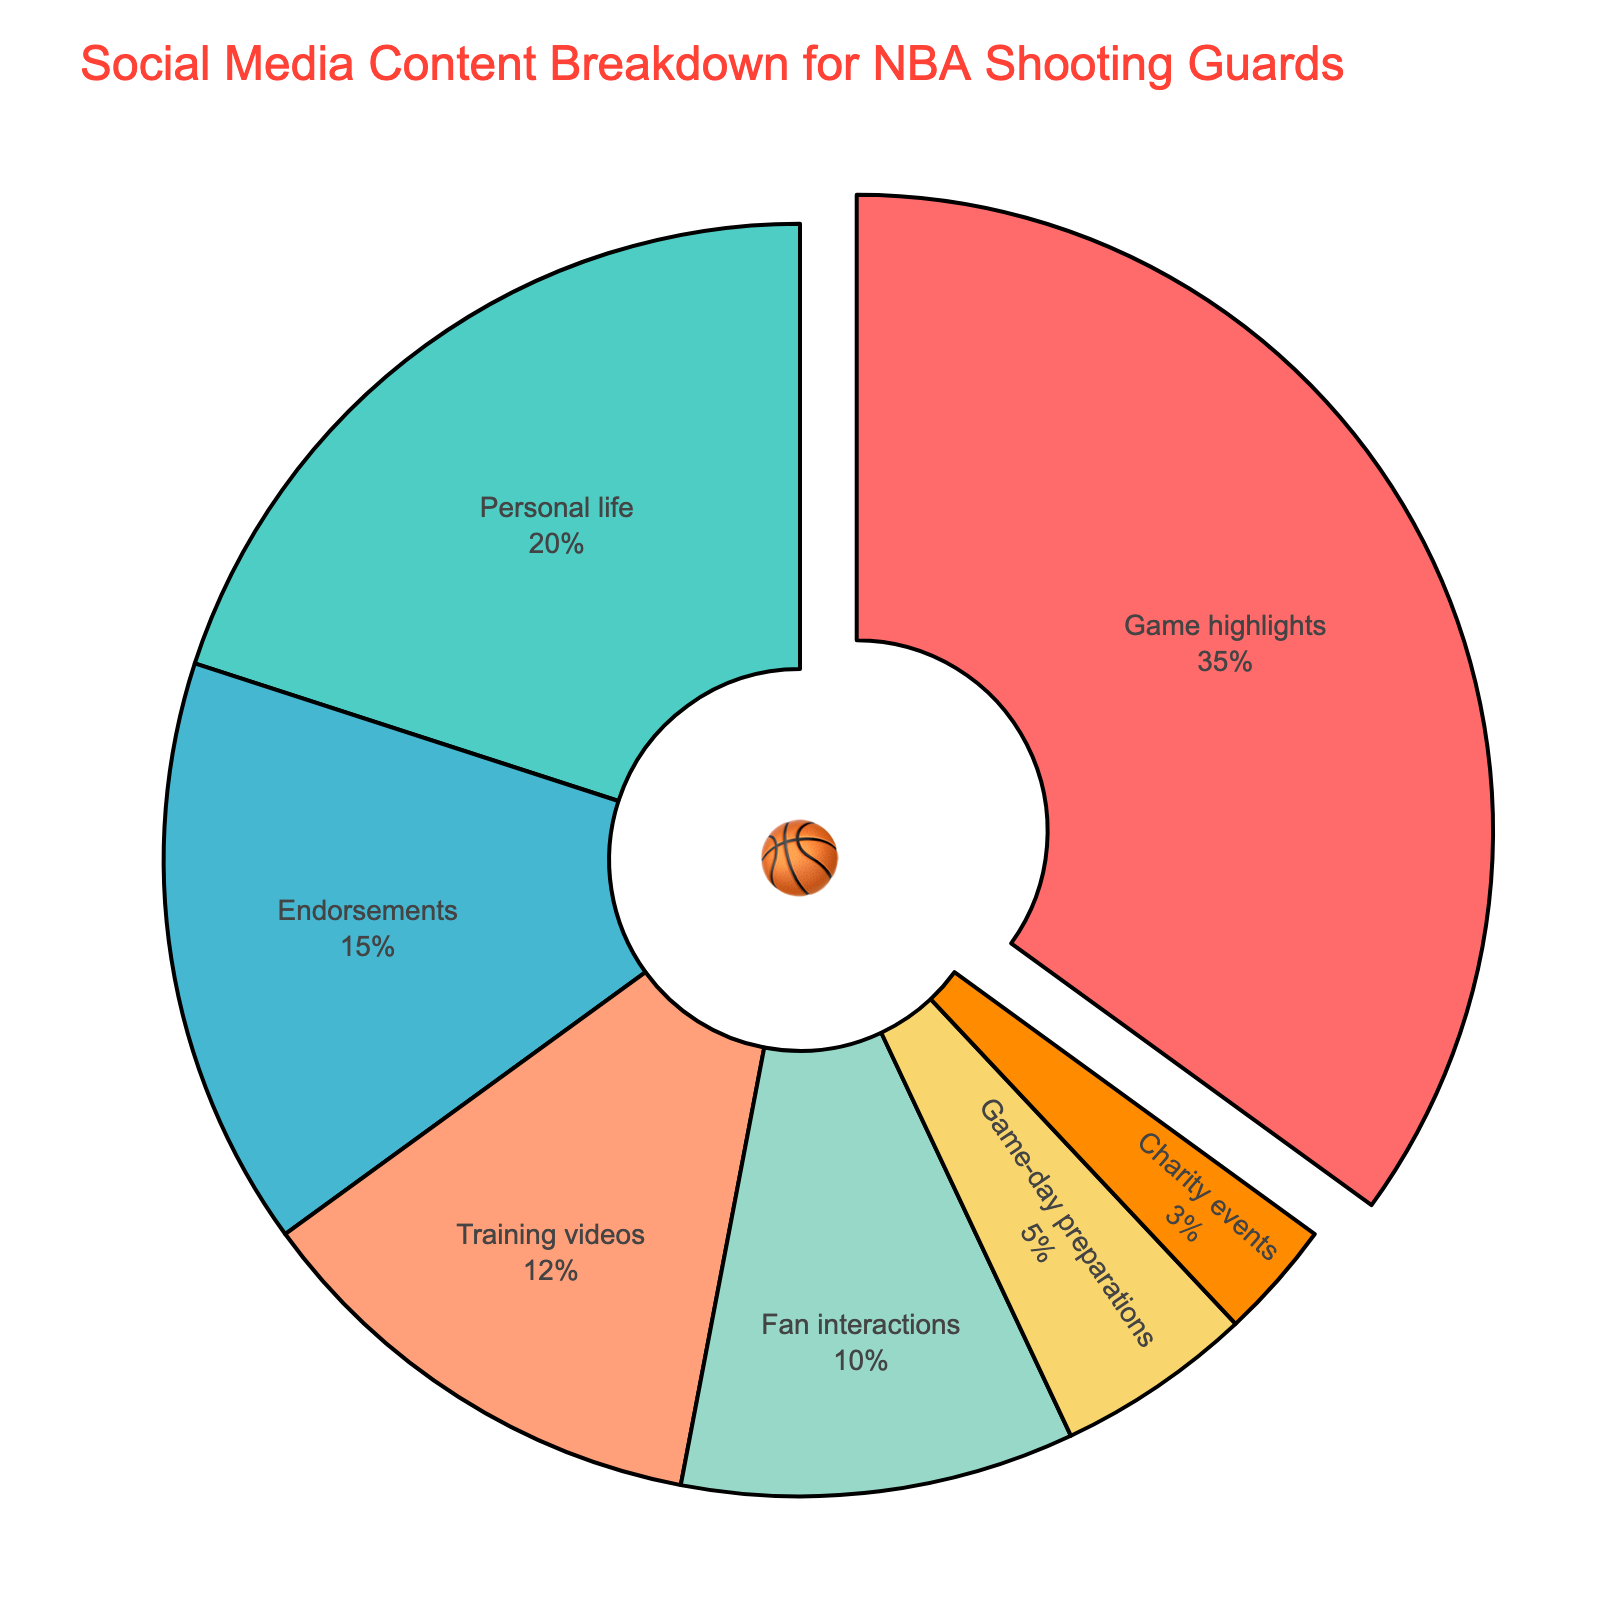How many percentage points more do game highlights have compared to endorsements? Game highlights have 35% while endorsements have 15%. The difference is 35% - 15% = 20 percentage points.
Answer: 20 Which content type shares the most percentage of social media content? Game highlights have the highest share with 35%.
Answer: Game highlights What is the sum of the percentages for personal life, endorsements, and training videos? Personal life is 20%, endorsements are 15%, and training videos are 12%. Adding them gives 20% + 15% + 12% = 47%.
Answer: 47% Are training videos more popular than fan interactions on social media? Training videos are 12% whereas fan interactions are 10%, so training videos are indeed more popular.
Answer: Yes What’s the percentage difference between fan interactions and game-day preparations? Fan interactions are at 10% while game-day preparations are at 5%. The difference is 10% - 5% = 5%.
Answer: 5 How much does the least shared content type contribute to the total percentage? Charity events contribute the least with 3%.
Answer: 3% Is the percentage for personal life content greater than the sum of game-day preparations and charity events? Personal life content is 20%, while game-day preparations and charity events add up to 5% + 3% = 8%. Therefore, 20% is greater than 8%.
Answer: Yes What visual attribute is used to emphasize game highlights in the pie chart? Game highlights are emphasized by being pulled out slightly from the pie chart compared to other sections.
Answer: Pulled out What content types together make up half of the pie chart? Game highlights (35%) and personal life (20%) together make up 55%, which is more than half. Training videos (12%) and endorsements (15%) together make up 27%, which is less than half. Pairing game highlights with either training videos (35%+12%=47%) or endorsements (35%+15%=50%) would exactly or closely sum up to half. So, game highlights and endorsements make exactly half.
Answer: Game highlights and endorsements 